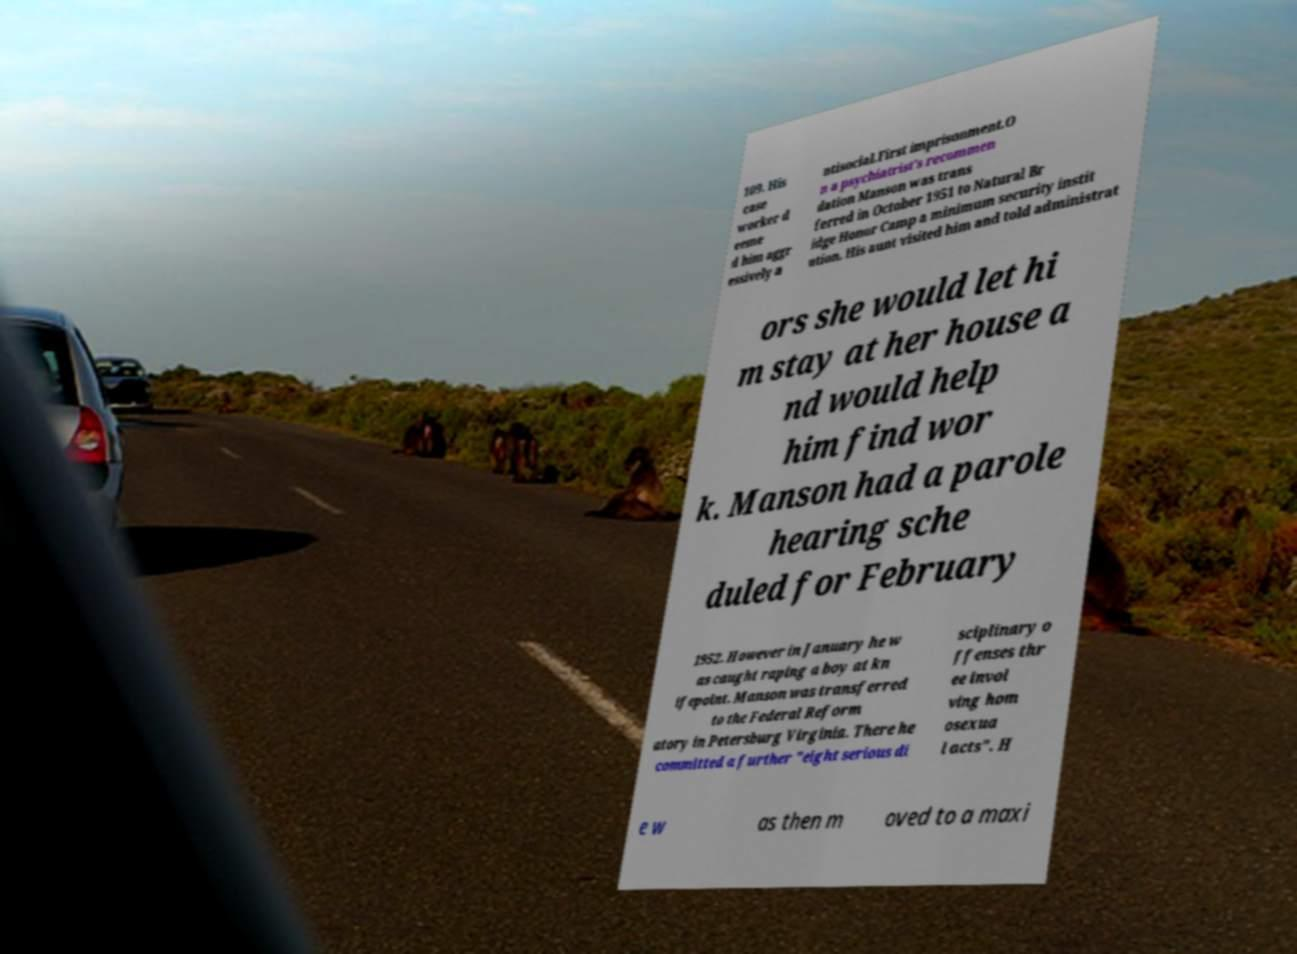Can you read and provide the text displayed in the image?This photo seems to have some interesting text. Can you extract and type it out for me? 109. His case worker d eeme d him aggr essively a ntisocial.First imprisonment.O n a psychiatrist's recommen dation Manson was trans ferred in October 1951 to Natural Br idge Honor Camp a minimum security instit ution. His aunt visited him and told administrat ors she would let hi m stay at her house a nd would help him find wor k. Manson had a parole hearing sche duled for February 1952. However in January he w as caught raping a boy at kn ifepoint. Manson was transferred to the Federal Reform atory in Petersburg Virginia. There he committed a further "eight serious di sciplinary o ffenses thr ee invol ving hom osexua l acts". H e w as then m oved to a maxi 